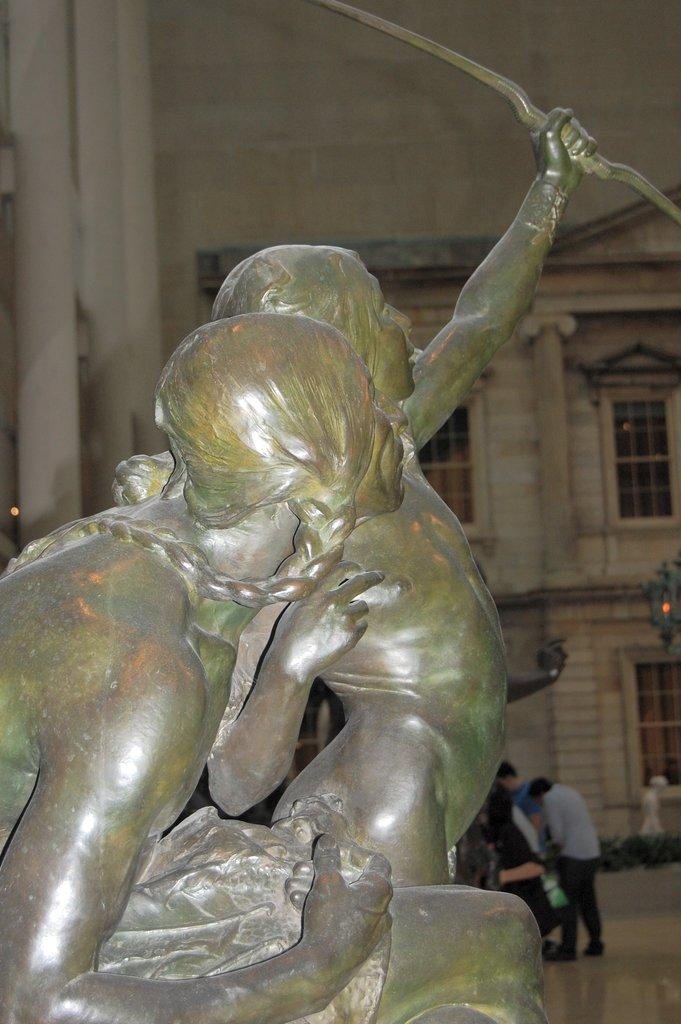What is depicted in the statue in the image? The statue in the image features two people holding an object. Are there any people near the statue? Yes, there are people standing behind the statue. What can be seen in the background of the image? There is a building in the background of the image. What type of loaf is being held by the people in the statue? There is no loaf present in the image; the statue features two people holding an object, but it is not specified as a loaf. 